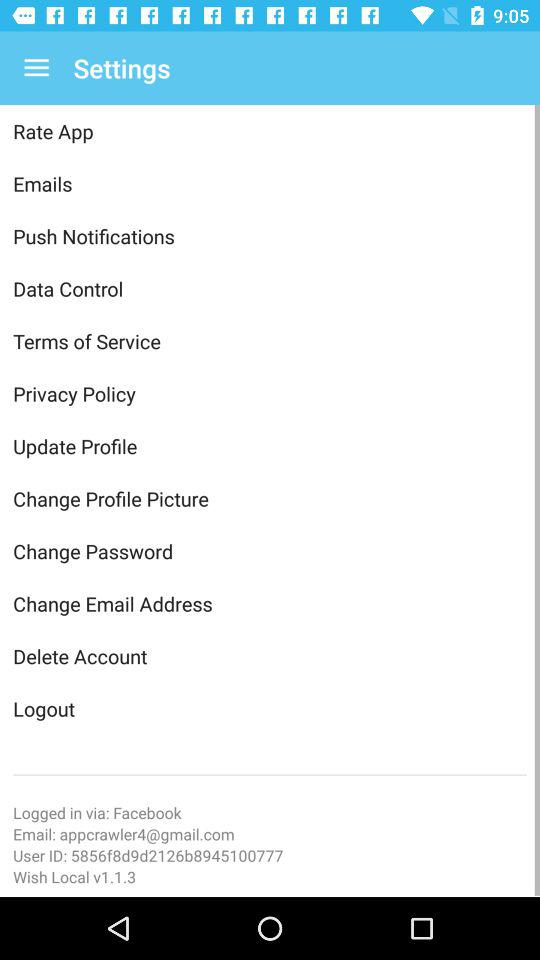What is the given user ID? The given user ID is 5856f8d9d2126b8945100777. 